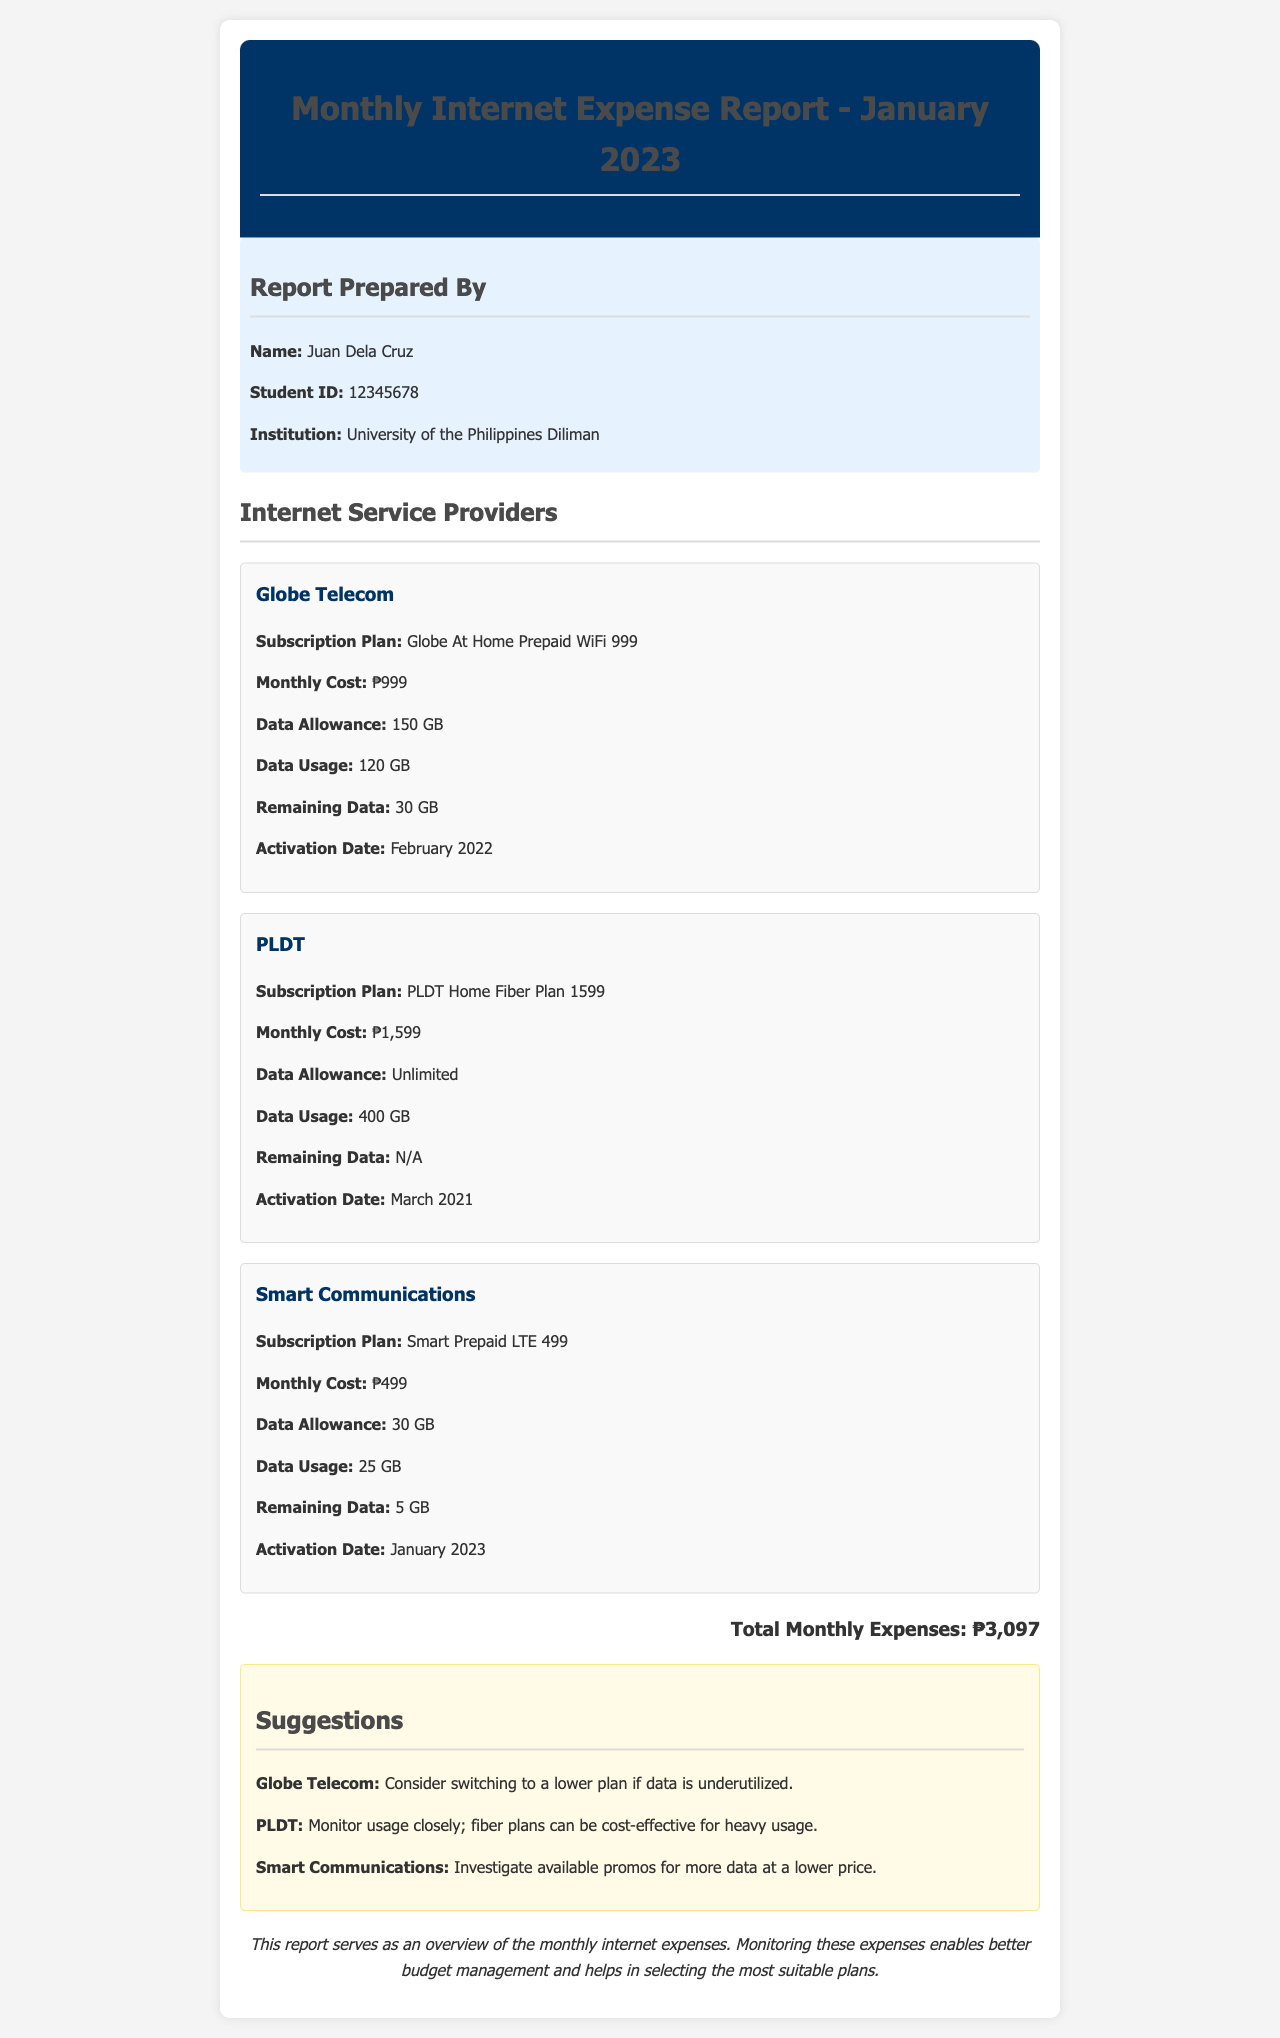What is the total monthly expense? The total monthly expense is listed at the bottom of the report, aggregating all subscription costs.
Answer: ₱3,097 What is the data allowance for PLDT? The data allowance for PLDT is specified in the ISP card section of the report.
Answer: Unlimited Who prepared the report? The report indicates the name of the person who prepared it in the header section.
Answer: Juan Dela Cruz What is the data usage for Smart Communications? The document details the data usage for Smart Communications in its ISP card.
Answer: 25 GB When was the Globe Telecom subscription activated? The activation date for Globe Telecom is mentioned in the subscription details.
Answer: February 2022 Which ISP has the highest monthly cost? The monthly costs for each ISP are listed, and the comparison identifies which is the highest.
Answer: PLDT What suggestion is made for Globe Telecom? The suggestions section contains specific recommendations for each ISP, including Globe Telecom.
Answer: Consider switching to a lower plan if data is underutilized What is the remaining data for Smart Communications? The remaining data for Smart Communications is explicitly stated in the ISP card section.
Answer: 5 GB How many gigabytes of data were used for the PLDT plan? The document specifies the data usage for PLDT in the ISP card.
Answer: 400 GB 